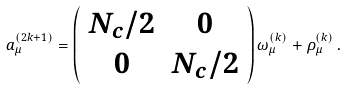<formula> <loc_0><loc_0><loc_500><loc_500>a _ { \mu } ^ { ( 2 k + 1 ) } = \left ( \begin{array} { c c } N _ { c } / 2 & 0 \\ 0 & N _ { c } / 2 \end{array} \right ) \omega ^ { ( k ) } _ { \mu } + \rho _ { \mu } ^ { ( k ) } \, .</formula> 